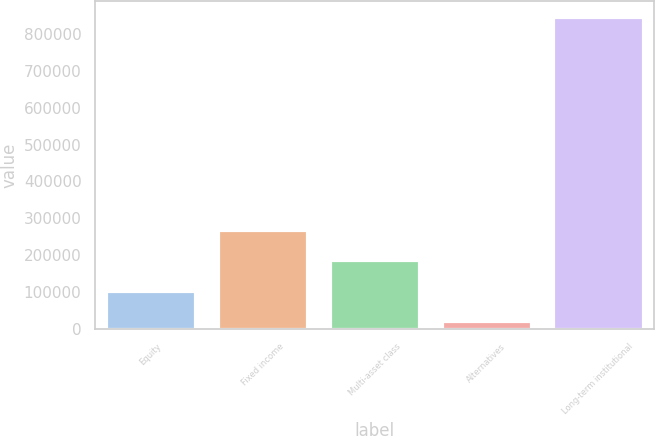Convert chart. <chart><loc_0><loc_0><loc_500><loc_500><bar_chart><fcel>Equity<fcel>Fixed income<fcel>Multi-asset class<fcel>Alternatives<fcel>Long-term institutional<nl><fcel>103239<fcel>268704<fcel>185971<fcel>20507<fcel>847829<nl></chart> 